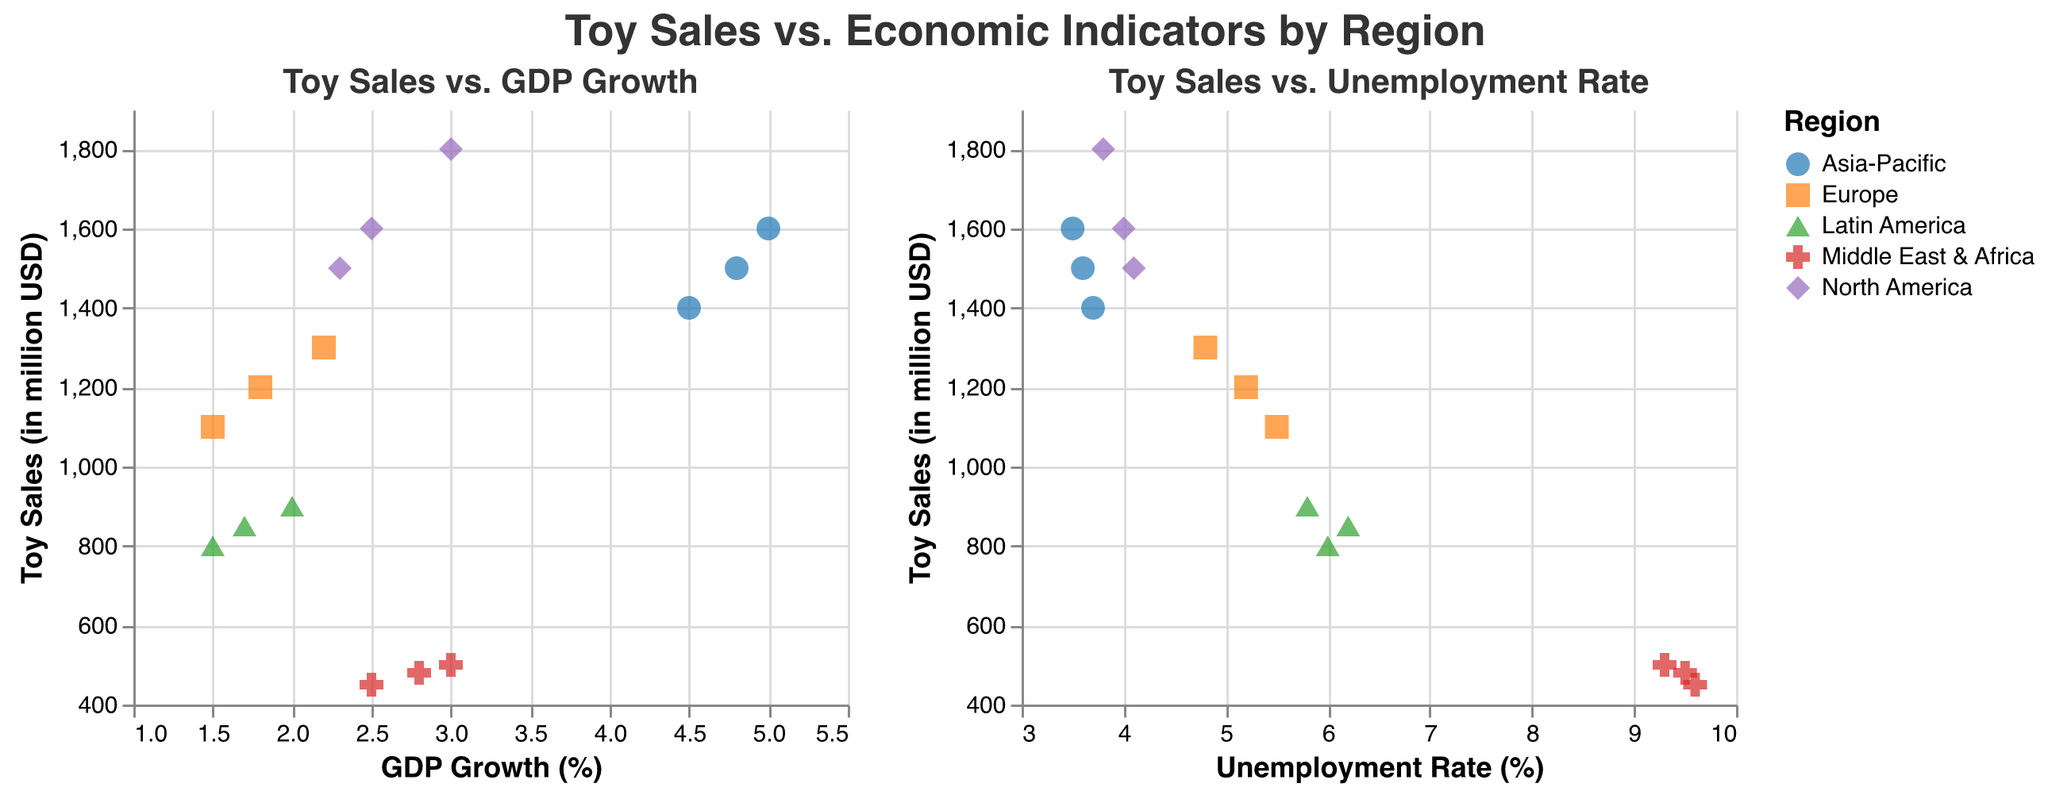How many regions are represented in the plot? The plot uses different colors and shapes to represent each region. By looking at the legend and the different shaped points, we can count the number of unique regions.
Answer: 5 What is the range of GDP Growth (%) shown in the Toy Sales vs. GDP Growth subplot? The x-axis of the Toy Sales vs. GDP Growth subplot displays the range for GDP Growth (%). By looking at the axis and the min and max values, we can determine the range. The scale is from 1% to 5.5%.
Answer: 1% to 5.5% Which region has the highest toy sales and what is the corresponding GDP Growth rate? By finding the highest point on the y-axis in the Toy Sales vs. GDP Growth subplot, we identify the region and then read the corresponding GDP Growth rate from the x-axis. The North America region has the highest toy sales of 1800 million USD with a GDP Growth of 3.0%.
Answer: North America, 3.0% Which subplot shows toy sales vs. unemployment rate? By observing the titles of the two subplots, we can determine which one addresses unemployment rate. The right subplot is titled “Toy Sales vs. Unemployment Rate.”
Answer: The right subplot In which region do toy sales appear to have the least correlation with GDP Growth? Why? By visually inspecting the spread and clustering of data points in the Toy Sales vs. GDP Growth subplot, we can determine the region with the least clear correlation. Middle East & Africa has toy sales varying much even though GDP Growth stays relatively consistent around 2.5% to 3.0%.
Answer: Middle East & Africa Compare the toy sales in relation to GDP Growth (%) for North America and Europe. Which region shows higher variability in toy sales? We compare the spread of data points across different GDP Growth (%) for both regions. North America toy sales range from 1500 to 1800 million USD, while Europe ranges from 1100 to 1300 million USD. This larger range indicates higher variability in toy sales for North America.
Answer: North America What can you infer about the relationship between unemployment rate and toy sales in the Middle East & Africa? In the right subplot, by examining the points for Middle East & Africa, we observe changes in toy sales versus the unemployment rate. As the unemployment rate increases, toy sales tend to decrease slightly but remain relatively low ranging from 450 to 500 million USD.
Answer: As the unemployment rate increases, toy sales slightly decrease Which two regions have nearly similar toy sales at different GDP Growth rates? By identifying overlapping or closely situated points on the Toy Sales vs. GDP Growth subplot, we find Asia-Pacific and North America both have toy sales around 1600 million USD but at different GDP Growth rates of 5.0% and 2.5% respectively.
Answer: Asia-Pacific and North America In the context of unemployment rates, what can be inferred about Latin America's toy sales compared with Europe? By comparing the positions of the data points for Latin America and Europe in the Toy Sales vs. Unemployment Rate subplot, we see that Latin America has lower toy sales despite similar unemployment rates (around 1.5% to 2.0%). Latin America’s toy sales peak at 900 million USD while Europe’s peak at 1300 million USD.
Answer: Latin America has lower toy sales than Europe at similar unemployment rates What trend is observed in the Asia-Pacific region's toy sales in relation to GDP Growth (%)? Observing the data points of the Asia-Pacific region in the Toy Sales vs. GDP Growth subplot, we see that toy sales generally increase as GDP Growth (%) increases, indicating a positive trend.
Answer: Toy sales increase as GDP Growth (%) increases 